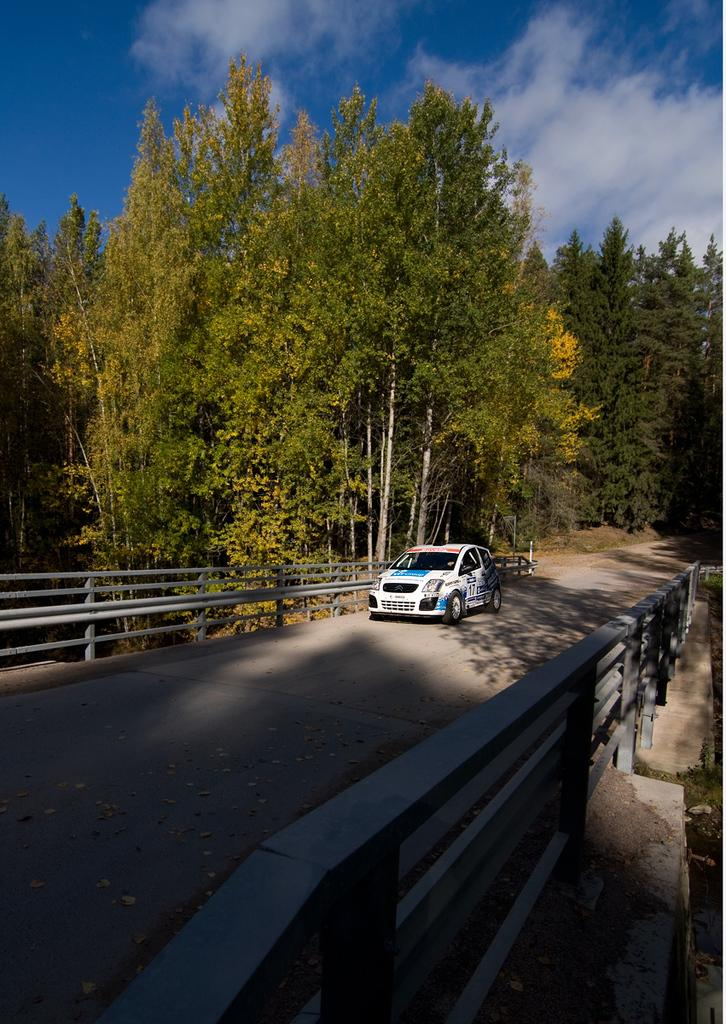What is the main subject of the image? There is a car on the road in the image. What can be seen on both sides of the road? There are railings on both sides of the road. What is visible in the background of the image? Trees and the sky are visible in the background of the image. What is the condition of the sky in the image? Clouds are present in the sky. Can you see any lizards crawling on the car in the image? There are no lizards visible on the car in the image; it only shows a car on the road with railings, trees, and clouds in the sky. 